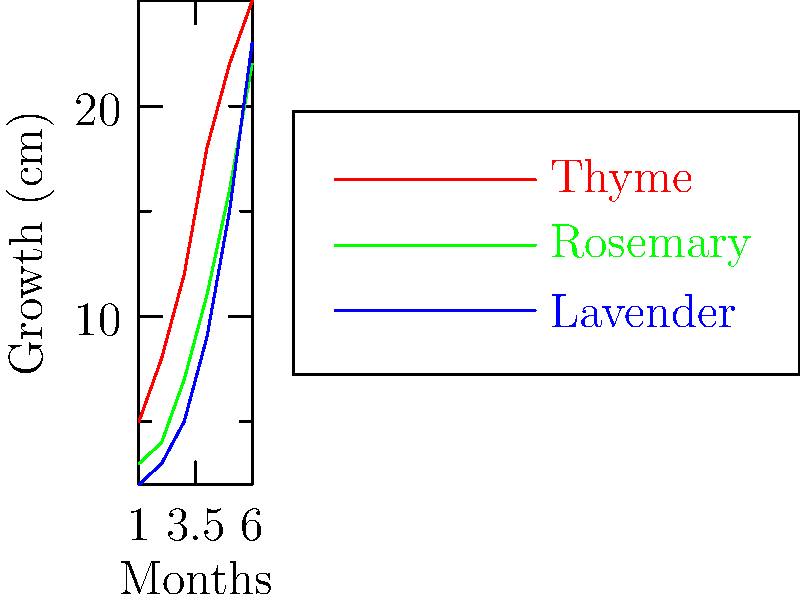Based on the line graph showing the growth patterns of thyme, rosemary, and lavender over six months, which herb exhibits the most consistent growth rate throughout the entire period? To determine which herb has the most consistent growth rate, we need to analyze the slope of each line:

1. Thyme (red line):
   - Months 1-2: Steep increase
   - Months 2-4: Slightly less steep, but still rapid growth
   - Months 4-6: Growth rate slows down significantly

2. Rosemary (green line):
   - Months 1-3: Slow, steady growth
   - Months 3-6: Growth rate increases, becoming steeper

3. Lavender (blue line):
   - Months 1-3: Slow, steady growth
   - Months 3-6: Growth rate increases consistently, maintaining a relatively uniform slope

Comparing these patterns:
- Thyme shows variable growth rates, fast at first and then slowing down.
- Rosemary has two distinct growth phases, slow then fast.
- Lavender maintains the most consistent slope throughout the six months, with a gradual increase in growth rate that remains relatively uniform.

Therefore, lavender exhibits the most consistent growth rate throughout the entire period.
Answer: Lavender 